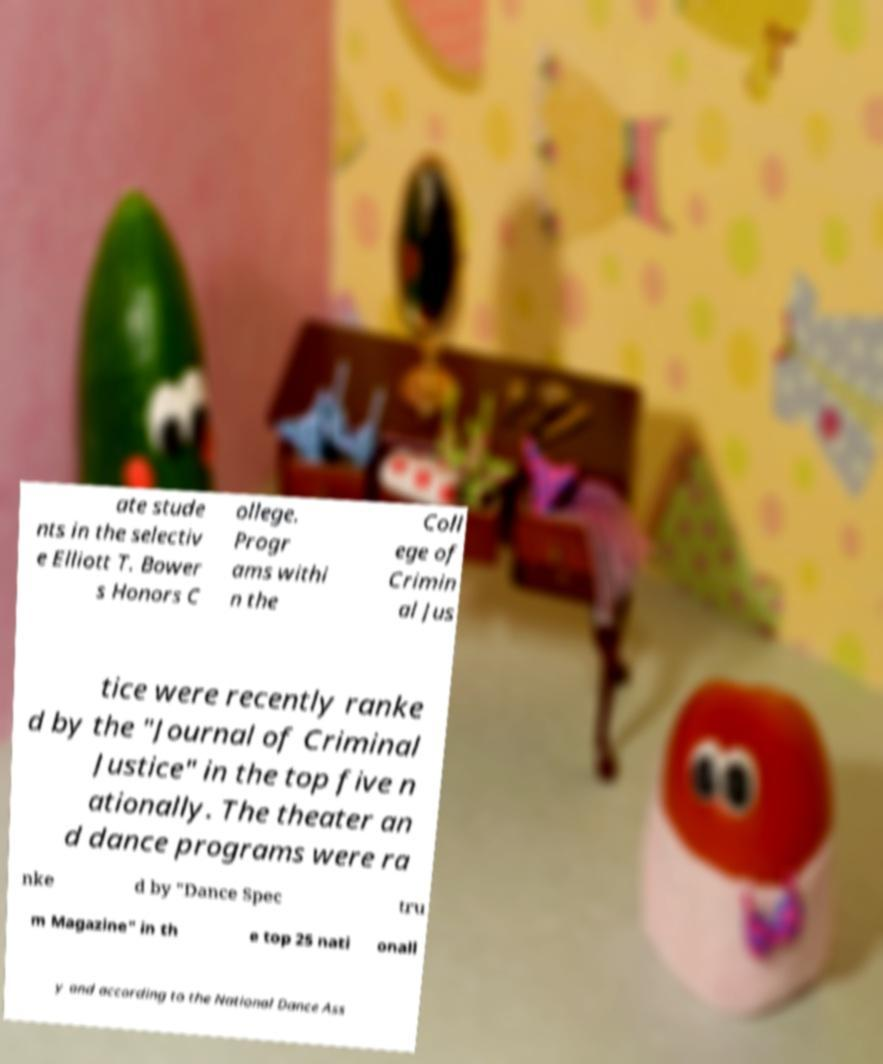Could you extract and type out the text from this image? ate stude nts in the selectiv e Elliott T. Bower s Honors C ollege. Progr ams withi n the Coll ege of Crimin al Jus tice were recently ranke d by the "Journal of Criminal Justice" in the top five n ationally. The theater an d dance programs were ra nke d by "Dance Spec tru m Magazine" in th e top 25 nati onall y and according to the National Dance Ass 